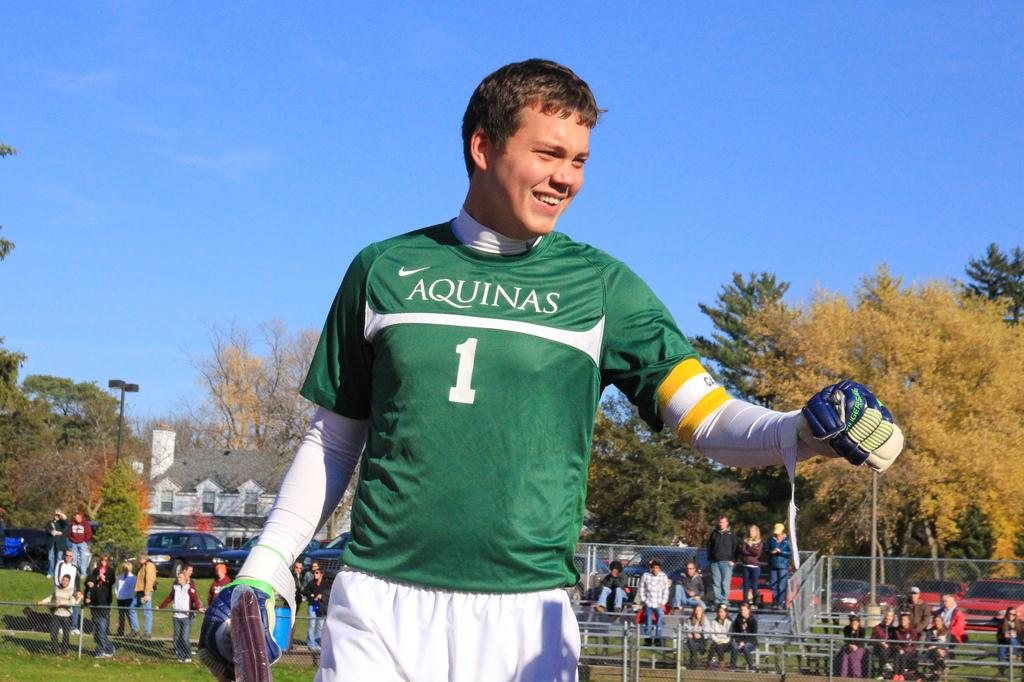Provide a one-sentence caption for the provided image. A player wearing a green Aquinas jersey looks happy on the field. 